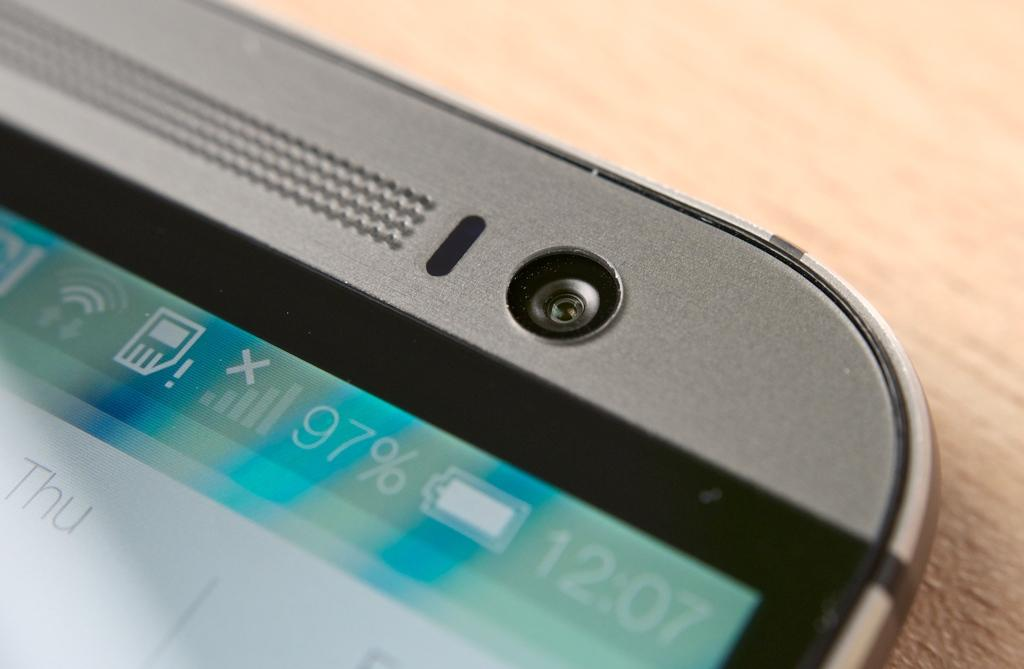<image>
Describe the image concisely. The top corner of a phone that is 97% charged 